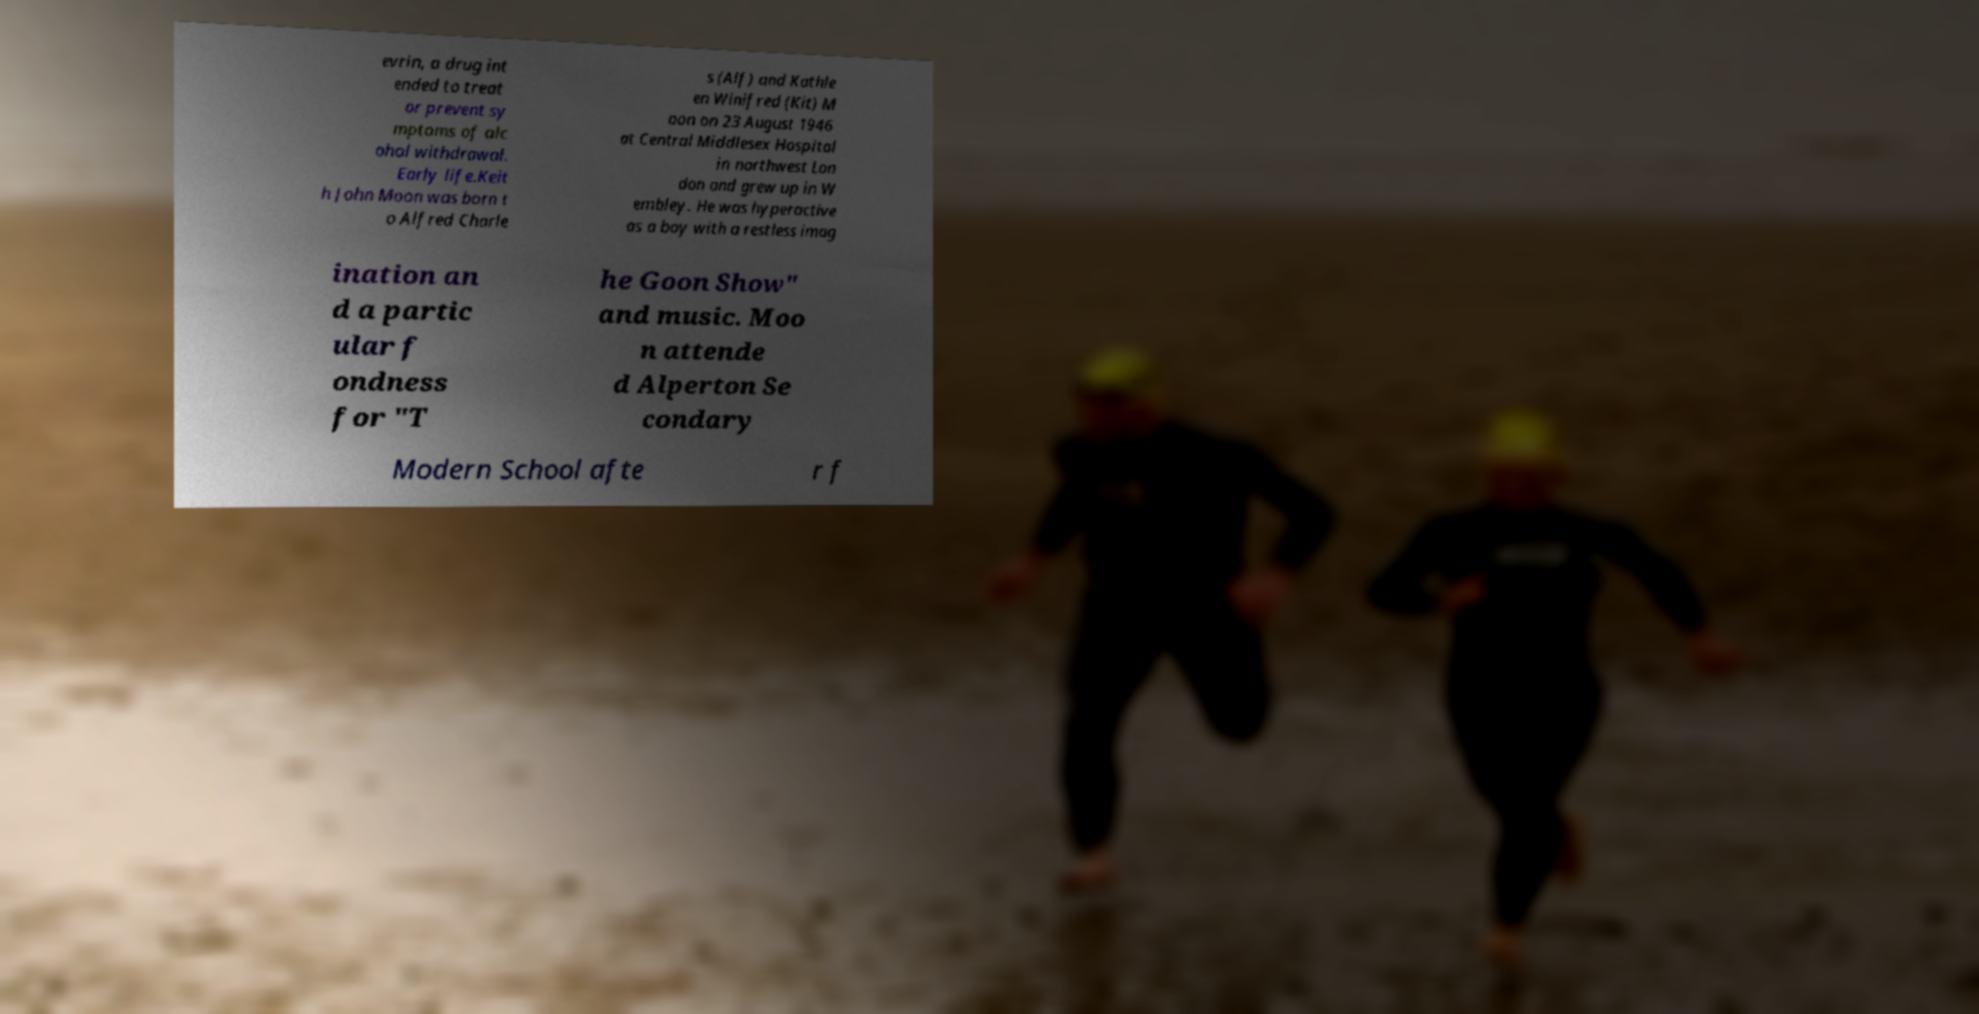I need the written content from this picture converted into text. Can you do that? evrin, a drug int ended to treat or prevent sy mptoms of alc ohol withdrawal. Early life.Keit h John Moon was born t o Alfred Charle s (Alf) and Kathle en Winifred (Kit) M oon on 23 August 1946 at Central Middlesex Hospital in northwest Lon don and grew up in W embley. He was hyperactive as a boy with a restless imag ination an d a partic ular f ondness for "T he Goon Show" and music. Moo n attende d Alperton Se condary Modern School afte r f 